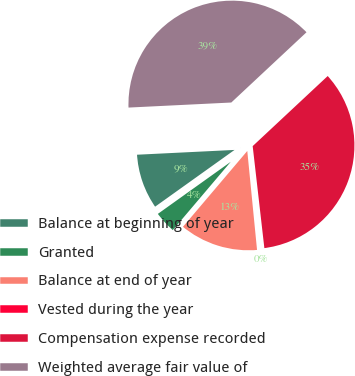Convert chart to OTSL. <chart><loc_0><loc_0><loc_500><loc_500><pie_chart><fcel>Balance at beginning of year<fcel>Granted<fcel>Balance at end of year<fcel>Vested during the year<fcel>Compensation expense recorded<fcel>Weighted average fair value of<nl><fcel>9.09%<fcel>3.93%<fcel>12.76%<fcel>0.25%<fcel>35.14%<fcel>38.82%<nl></chart> 